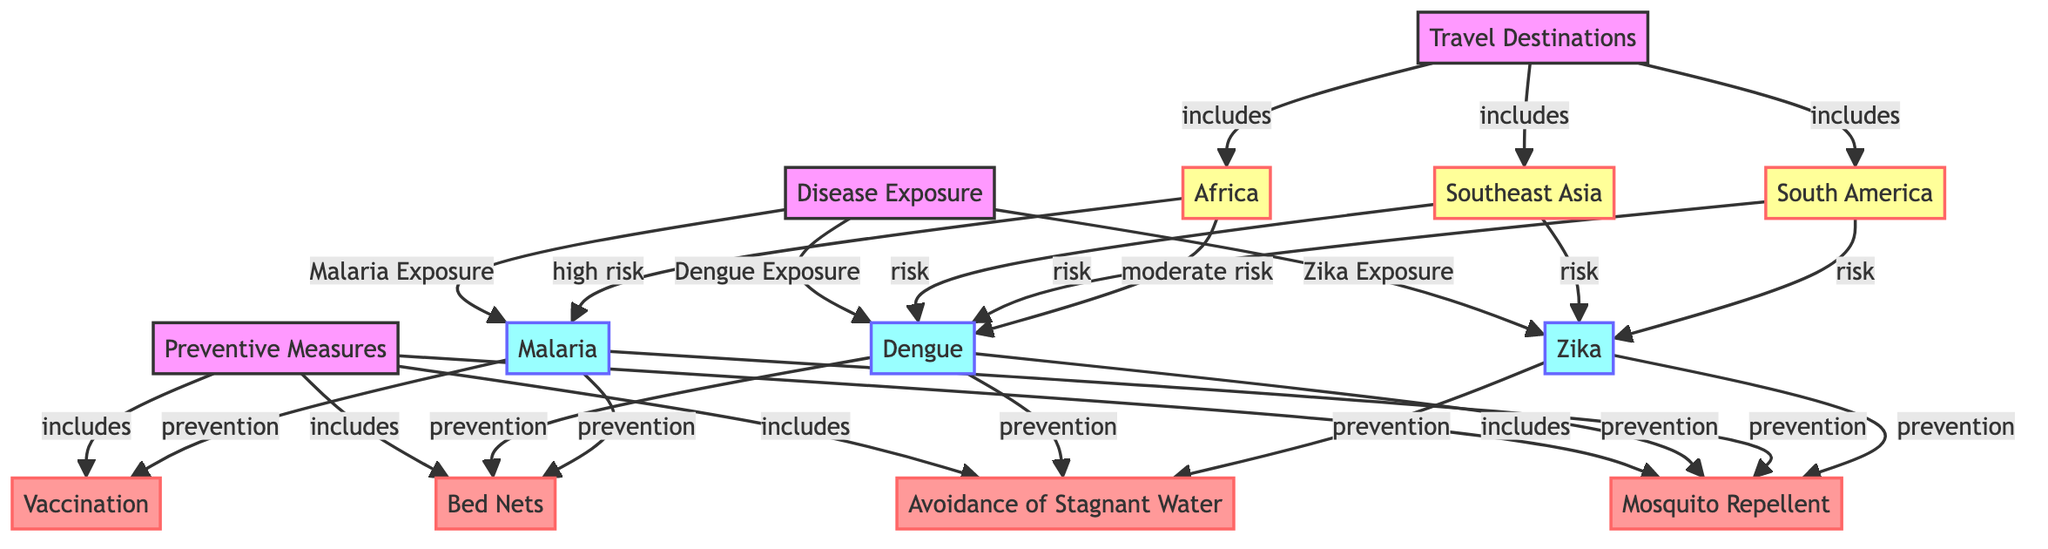What regions are included as travel destinations in the diagram? The diagram lists three regions under the "Travel Destinations" node: Southeast Asia, South America, and Africa.
Answer: Southeast Asia, South America, Africa How many diseases are represented in the disease exposure section of the diagram? There are three diseases in the "Disease Exposure" section: Dengue, Malaria, and Zika.
Answer: 3 What preventive measure is linked specifically to Malaria? The diagram indicates that the preventive measure linked to Malaria is vaccination, which is specifically associated with the Malaria exposure node.
Answer: Vaccination Which region has a high risk of Malaria exposure? The diagram shows that Africa has a "high risk" associated with Malaria exposure, indicating a significant risk level for travelers in that region.
Answer: Africa How many preventive measures are listed in the diagram? The diagram lists four preventive measures: Vaccination, Mosquito Repellent, Bed Nets, and Avoidance of Stagnant Water, totaling four measures.
Answer: 4 Which diseases are connected to Southeast Asia in terms of risk? The diagram indicates that Southeast Asia has a risk associated with Dengue and Zika, indicating that both diseases pose a threat in that region.
Answer: Dengue, Zika What is the prevention measure associated with Zika exposure? The diagram specifies that avoidance of stagnant water and mosquito repellent are prevention measures connected to the Zika exposure node.
Answer: Avoidance of Stagnant Water, Mosquito Repellent Which region is indicated as having a moderate risk for Dengue? The diagram identifies Africa as having a "moderate risk" for Dengue exposure, which suggests that while there is a risk, it is not as high as for Malaria.
Answer: Africa What is the role of Bed Nets in disease prevention according to the diagram? Bed Nets are shown as a preventive measure connected to both Malaria and Dengue exposure, indicating their effectiveness in reducing risk for both diseases.
Answer: Preventive Measure for Malaria and Dengue 